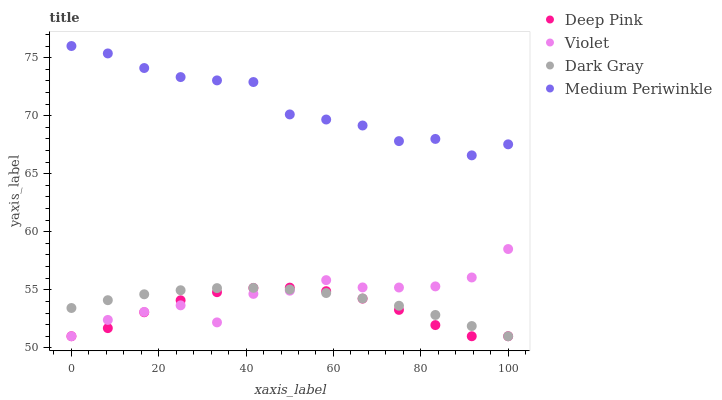Does Deep Pink have the minimum area under the curve?
Answer yes or no. Yes. Does Medium Periwinkle have the maximum area under the curve?
Answer yes or no. Yes. Does Medium Periwinkle have the minimum area under the curve?
Answer yes or no. No. Does Deep Pink have the maximum area under the curve?
Answer yes or no. No. Is Dark Gray the smoothest?
Answer yes or no. Yes. Is Violet the roughest?
Answer yes or no. Yes. Is Deep Pink the smoothest?
Answer yes or no. No. Is Deep Pink the roughest?
Answer yes or no. No. Does Dark Gray have the lowest value?
Answer yes or no. Yes. Does Medium Periwinkle have the lowest value?
Answer yes or no. No. Does Medium Periwinkle have the highest value?
Answer yes or no. Yes. Does Deep Pink have the highest value?
Answer yes or no. No. Is Deep Pink less than Medium Periwinkle?
Answer yes or no. Yes. Is Medium Periwinkle greater than Deep Pink?
Answer yes or no. Yes. Does Dark Gray intersect Deep Pink?
Answer yes or no. Yes. Is Dark Gray less than Deep Pink?
Answer yes or no. No. Is Dark Gray greater than Deep Pink?
Answer yes or no. No. Does Deep Pink intersect Medium Periwinkle?
Answer yes or no. No. 